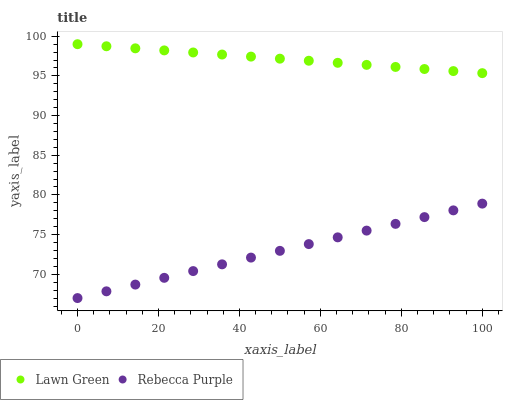Does Rebecca Purple have the minimum area under the curve?
Answer yes or no. Yes. Does Lawn Green have the maximum area under the curve?
Answer yes or no. Yes. Does Rebecca Purple have the maximum area under the curve?
Answer yes or no. No. Is Lawn Green the smoothest?
Answer yes or no. Yes. Is Rebecca Purple the roughest?
Answer yes or no. Yes. Is Rebecca Purple the smoothest?
Answer yes or no. No. Does Rebecca Purple have the lowest value?
Answer yes or no. Yes. Does Lawn Green have the highest value?
Answer yes or no. Yes. Does Rebecca Purple have the highest value?
Answer yes or no. No. Is Rebecca Purple less than Lawn Green?
Answer yes or no. Yes. Is Lawn Green greater than Rebecca Purple?
Answer yes or no. Yes. Does Rebecca Purple intersect Lawn Green?
Answer yes or no. No. 